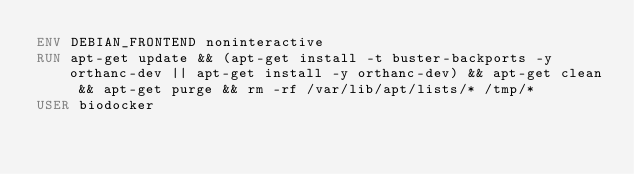Convert code to text. <code><loc_0><loc_0><loc_500><loc_500><_Dockerfile_>ENV DEBIAN_FRONTEND noninteractive
RUN apt-get update && (apt-get install -t buster-backports -y orthanc-dev || apt-get install -y orthanc-dev) && apt-get clean && apt-get purge && rm -rf /var/lib/apt/lists/* /tmp/*
USER biodocker
</code> 